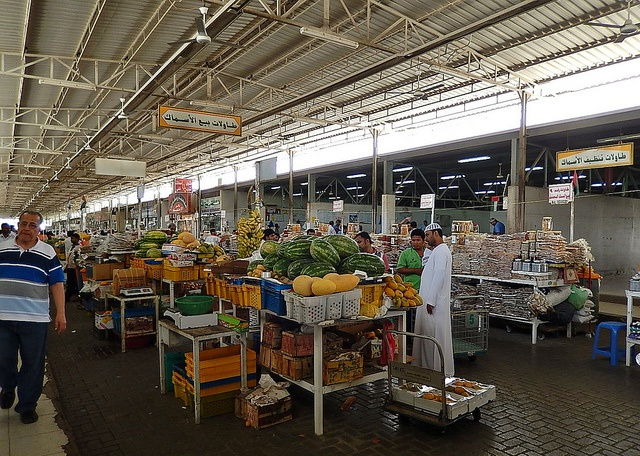Describe the objects in this image and their specific colors. I can see people in gray, black, darkgray, and navy tones, people in gray, darkgray, and black tones, people in gray, black, darkgreen, and maroon tones, banana in gray, olive, black, and tan tones, and bowl in gray, black, and darkgreen tones in this image. 